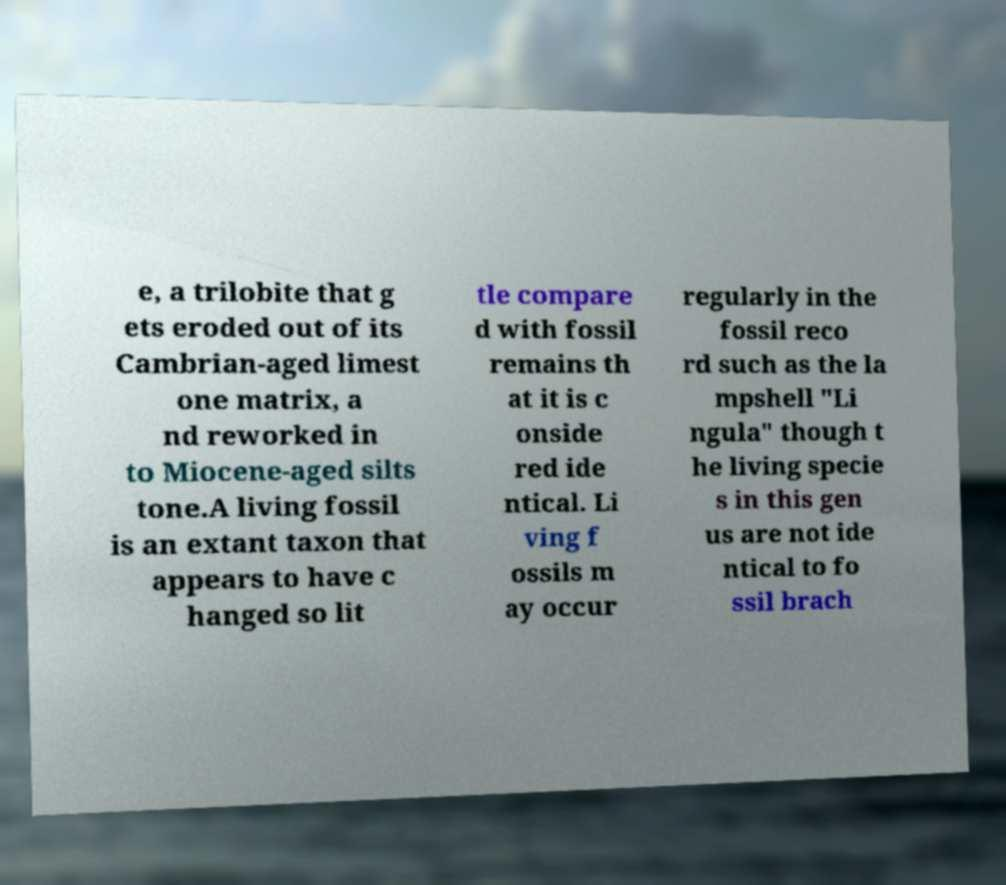Could you assist in decoding the text presented in this image and type it out clearly? e, a trilobite that g ets eroded out of its Cambrian-aged limest one matrix, a nd reworked in to Miocene-aged silts tone.A living fossil is an extant taxon that appears to have c hanged so lit tle compare d with fossil remains th at it is c onside red ide ntical. Li ving f ossils m ay occur regularly in the fossil reco rd such as the la mpshell "Li ngula" though t he living specie s in this gen us are not ide ntical to fo ssil brach 